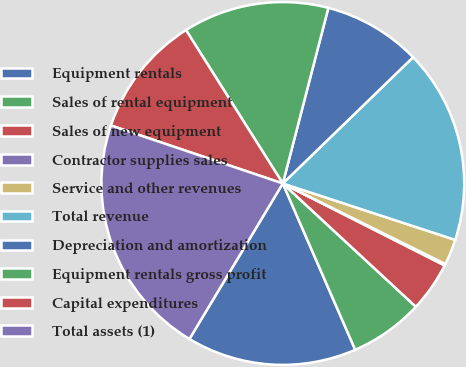Convert chart to OTSL. <chart><loc_0><loc_0><loc_500><loc_500><pie_chart><fcel>Equipment rentals<fcel>Sales of rental equipment<fcel>Sales of new equipment<fcel>Contractor supplies sales<fcel>Service and other revenues<fcel>Total revenue<fcel>Depreciation and amortization<fcel>Equipment rentals gross profit<fcel>Capital expenditures<fcel>Total assets (1)<nl><fcel>15.14%<fcel>6.57%<fcel>4.43%<fcel>0.14%<fcel>2.29%<fcel>17.28%<fcel>8.71%<fcel>13.0%<fcel>10.86%<fcel>21.57%<nl></chart> 